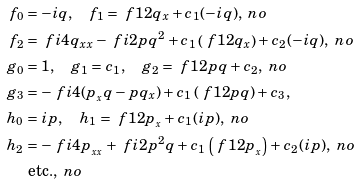Convert formula to latex. <formula><loc_0><loc_0><loc_500><loc_500>f _ { 0 } & = - i q , \quad f _ { 1 } = \ f 1 2 q _ { x } + c _ { 1 } ( - i q ) , \ n o \\ f _ { 2 } & = \ f { i } { 4 } q _ { x x } - \ f { i } { 2 } p q ^ { 2 } + c _ { 1 } \left ( \ f 1 2 q _ { x } \right ) + c _ { 2 } ( - i q ) , \ n o \\ g _ { 0 } & = 1 , \quad g _ { 1 } = c _ { 1 } , \quad g _ { 2 } = \ f 1 2 p q + c _ { 2 } , \ n o \\ g _ { 3 } & = - \ f { i } { 4 } ( p _ { _ { x } } q - p q _ { x } ) + c _ { 1 } \left ( \ f 1 2 p q \right ) + c _ { 3 } , \\ h _ { 0 } & = i p , \quad h _ { 1 } = \ f 1 2 p _ { _ { x } } + c _ { 1 } ( i p ) , \ n o \\ h _ { 2 } & = - \ f { i } { 4 } p _ { _ { x x } } + \ f { i } { 2 } p { ^ { 2 } } q + c _ { 1 } \left ( \ f 1 2 p _ { _ { x } } \right ) + c _ { 2 } ( i p ) , \ n o \\ & \text { etc.} , \ n o</formula> 